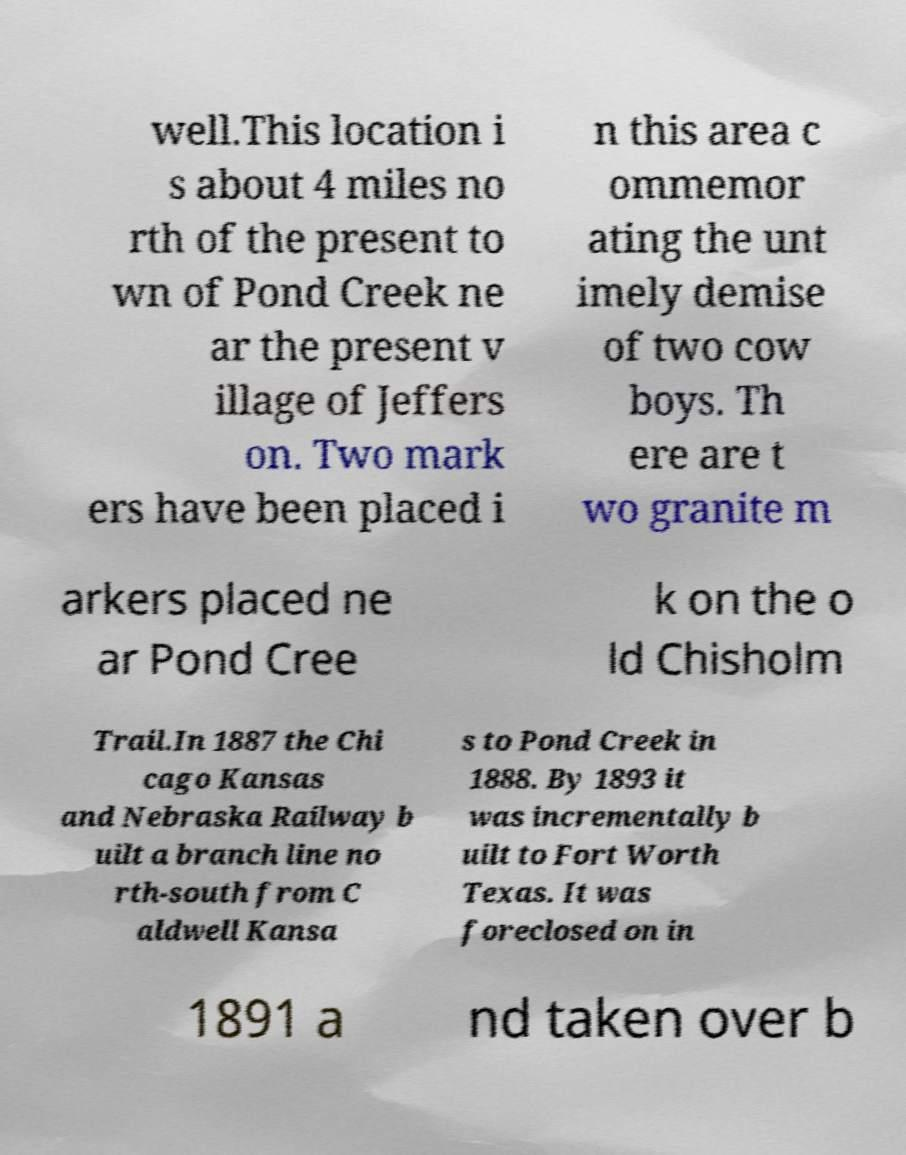There's text embedded in this image that I need extracted. Can you transcribe it verbatim? well.This location i s about 4 miles no rth of the present to wn of Pond Creek ne ar the present v illage of Jeffers on. Two mark ers have been placed i n this area c ommemor ating the unt imely demise of two cow boys. Th ere are t wo granite m arkers placed ne ar Pond Cree k on the o ld Chisholm Trail.In 1887 the Chi cago Kansas and Nebraska Railway b uilt a branch line no rth-south from C aldwell Kansa s to Pond Creek in 1888. By 1893 it was incrementally b uilt to Fort Worth Texas. It was foreclosed on in 1891 a nd taken over b 